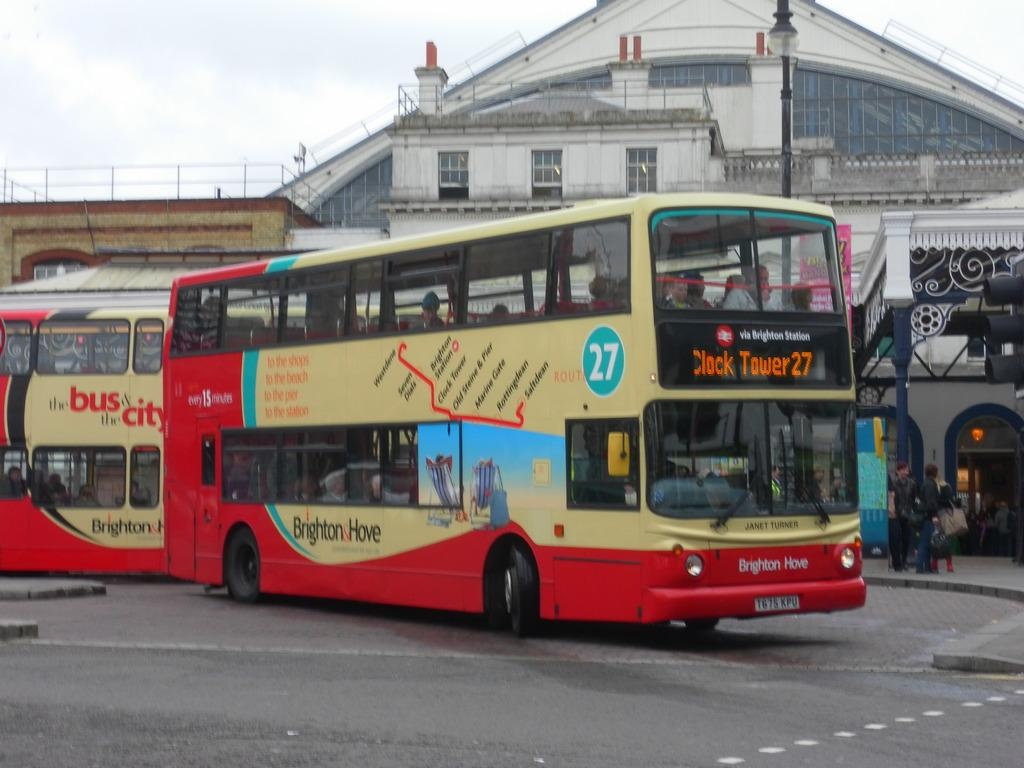<image>
Provide a brief description of the given image. A double decker bus headed for Clock Tower 27. 